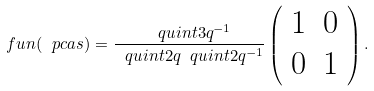<formula> <loc_0><loc_0><loc_500><loc_500>\ f u n ( \ p c a s ) = \frac { \ q u i n t { 3 } { q ^ { - 1 } } } { \ q u i n t { 2 } { q } \ q u i n t { 2 } { q ^ { - 1 } } } \left ( \begin{array} { c c } 1 & 0 \\ 0 & 1 \end{array} \right ) .</formula> 